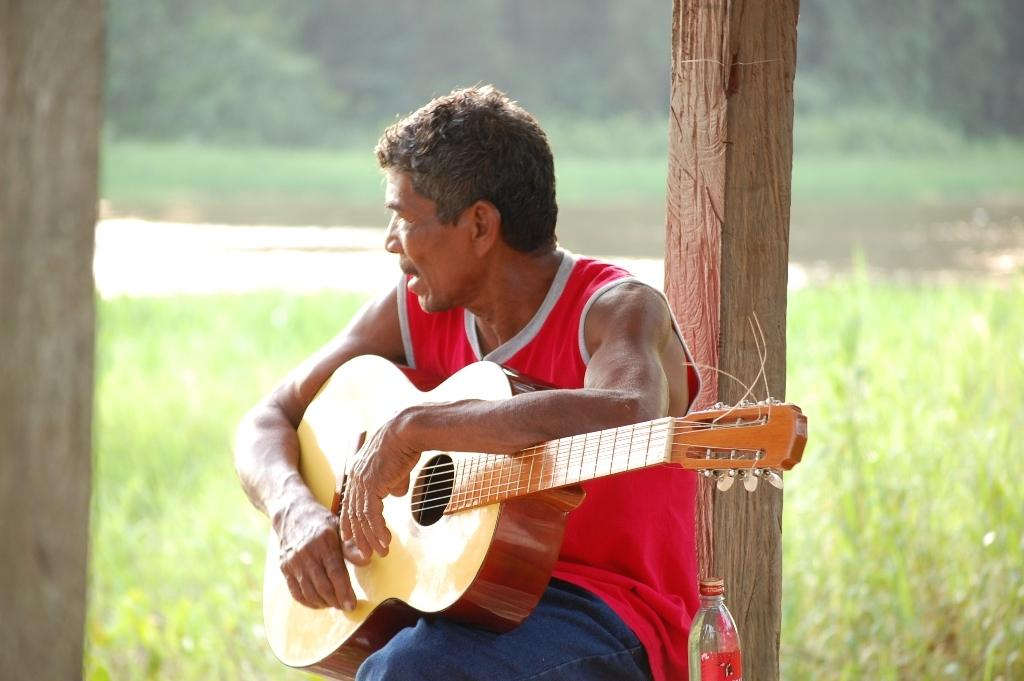What is the main subject of the image? There is a man in the image. What is the man doing in the image? The man is sitting in the image. What object is the man holding in his hand? The man is holding a guitar in his hand. What other objects can be seen in the image? There is a bottle and a wooden pole in the image. What type of natural environment is visible in the image? There is grass in the image. What type of harmony can be heard coming from the star in the image? There is no star present in the image, and therefore no harmony can be heard. 